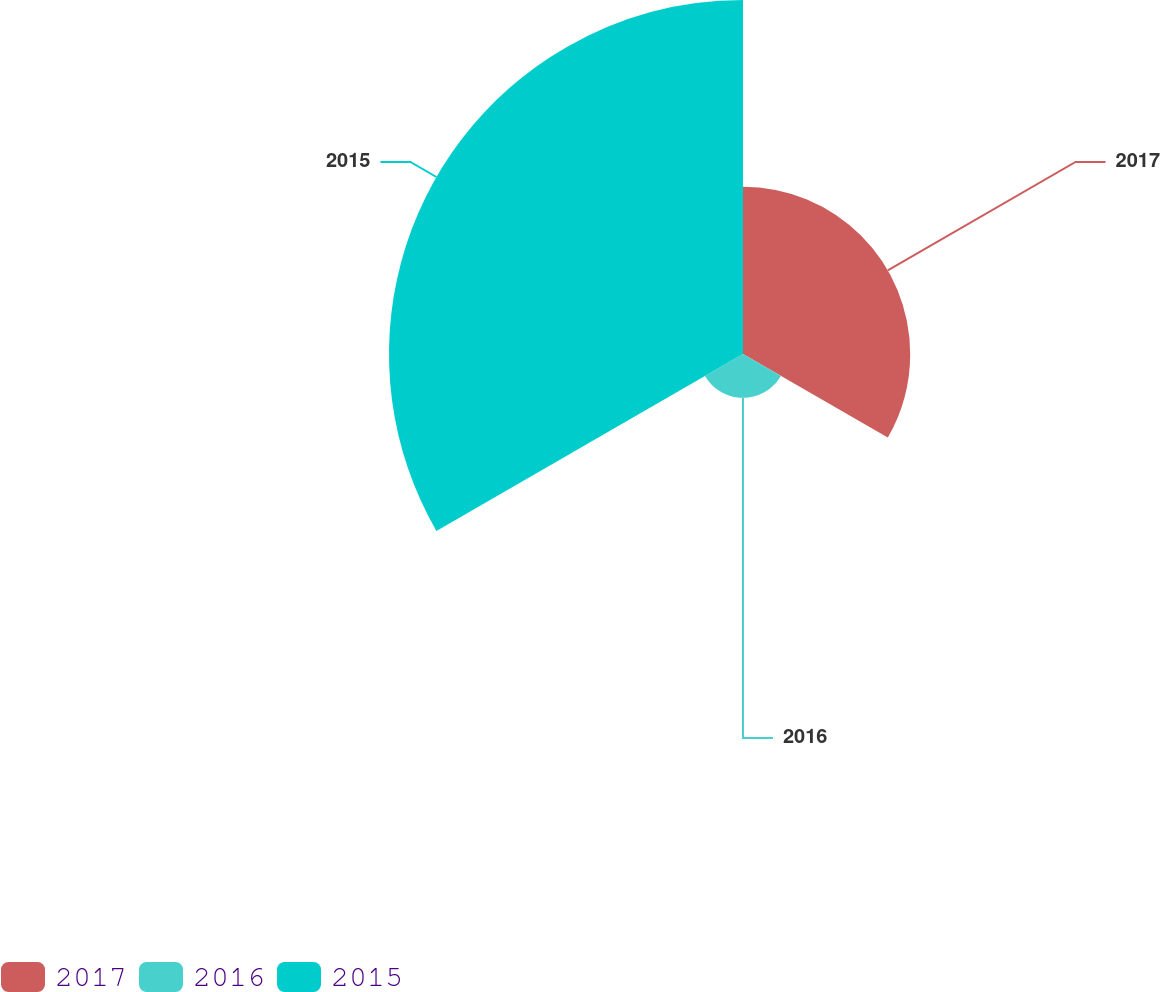Convert chart. <chart><loc_0><loc_0><loc_500><loc_500><pie_chart><fcel>2017<fcel>2016<fcel>2015<nl><fcel>29.59%<fcel>7.76%<fcel>62.65%<nl></chart> 